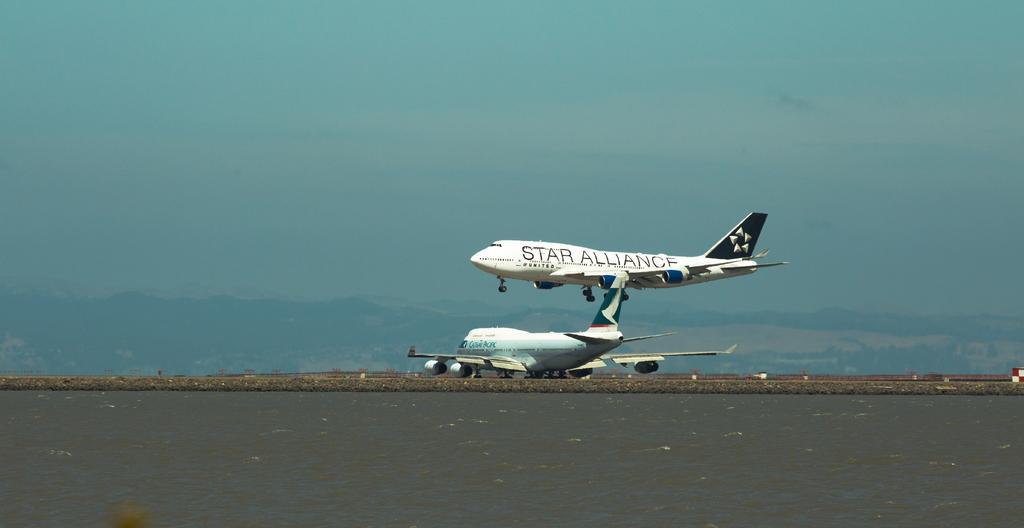Provide a one-sentence caption for the provided image. A plan taking off displaying the words Star Alliance. 